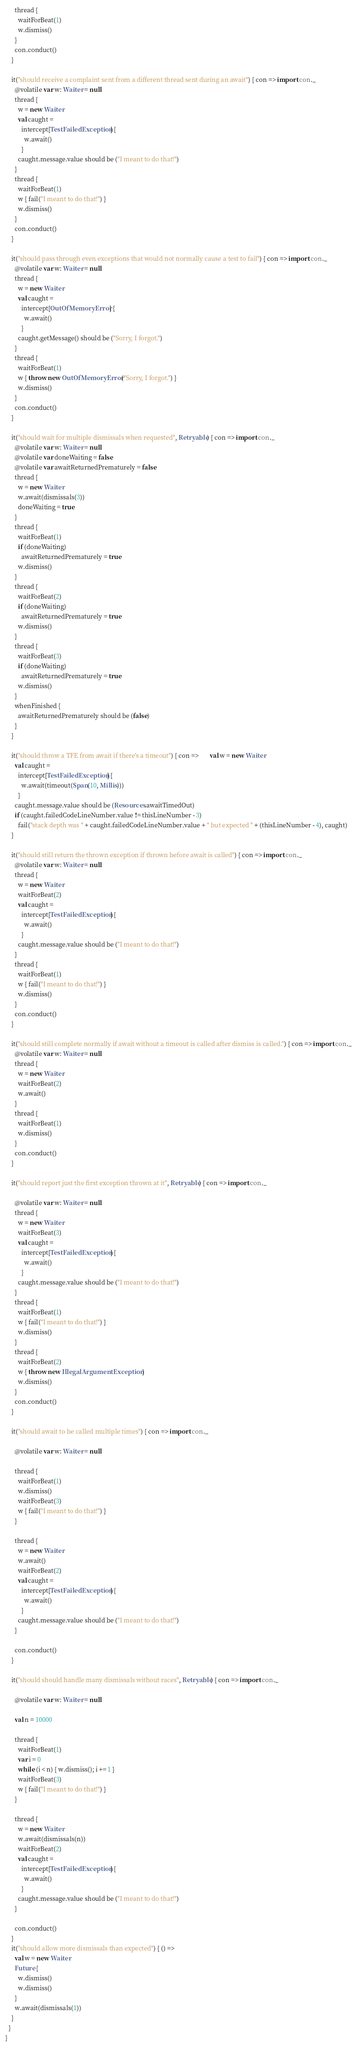<code> <loc_0><loc_0><loc_500><loc_500><_Scala_>      thread {
        waitForBeat(1)
        w.dismiss()
      }
      con.conduct()
    }

    it("should receive a complaint sent from a different thread sent during an await") { con => import con._
      @volatile var w: Waiter = null
      thread {
        w = new Waiter
        val caught =
          intercept[TestFailedException] {
            w.await()
          }
        caught.message.value should be ("I meant to do that!")
      }
      thread {
        waitForBeat(1)
        w { fail("I meant to do that!") }
        w.dismiss()
      }
      con.conduct()
    }

    it("should pass through even exceptions that would not normally cause a test to fail") { con => import con._
      @volatile var w: Waiter = null
      thread {
        w = new Waiter
        val caught =
          intercept[OutOfMemoryError] {
            w.await()
          }
        caught.getMessage() should be ("Sorry, I forgot.")
      }
      thread {
        waitForBeat(1)
        w { throw new OutOfMemoryError("Sorry, I forgot.") }
        w.dismiss()
      }
      con.conduct()
    }

    it("should wait for multiple dismissals when requested", Retryable) { con => import con._
      @volatile var w: Waiter = null
      @volatile var doneWaiting = false
      @volatile var awaitReturnedPrematurely = false
      thread {
        w = new Waiter
        w.await(dismissals(3))
        doneWaiting = true
      }
      thread {
        waitForBeat(1)
        if (doneWaiting)
          awaitReturnedPrematurely = true
        w.dismiss()
      }
      thread {
        waitForBeat(2)
        if (doneWaiting)
          awaitReturnedPrematurely = true
        w.dismiss()
      }
      thread {
        waitForBeat(3)
        if (doneWaiting)
          awaitReturnedPrematurely = true
        w.dismiss()
      }
      whenFinished {
        awaitReturnedPrematurely should be (false)
      }
    }

    it("should throw a TFE from await if there's a timeout") { con =>       val w = new Waiter
      val caught =
        intercept[TestFailedException] {
          w.await(timeout(Span(10, Millis)))
        }
      caught.message.value should be (Resources.awaitTimedOut)
      if (caught.failedCodeLineNumber.value != thisLineNumber - 3)
        fail("stack depth was " + caught.failedCodeLineNumber.value + " but expected " + (thisLineNumber - 4), caught)
    }

    it("should still return the thrown exception if thrown before await is called") { con => import con._
      @volatile var w: Waiter = null
      thread {
        w = new Waiter
        waitForBeat(2)
        val caught =
          intercept[TestFailedException] {
            w.await()
          }
        caught.message.value should be ("I meant to do that!")
      }
      thread {
        waitForBeat(1)
        w { fail("I meant to do that!") }
        w.dismiss()
      }
      con.conduct()
    }

    it("should still complete normally if await without a timeout is called after dismiss is called.") { con => import con._
      @volatile var w: Waiter = null
      thread {
        w = new Waiter
        waitForBeat(2)
        w.await()
      }
      thread {
        waitForBeat(1)
        w.dismiss()
      }
      con.conduct()
    }

    it("should report just the first exception thrown at it", Retryable) { con => import con._

      @volatile var w: Waiter = null
      thread {
        w = new Waiter
        waitForBeat(3)
        val caught =
          intercept[TestFailedException] {
            w.await()
          }
        caught.message.value should be ("I meant to do that!")
      }
      thread {
        waitForBeat(1)
        w { fail("I meant to do that!") }
        w.dismiss()
      }
      thread {
        waitForBeat(2)
        w { throw new IllegalArgumentException }
        w.dismiss()
      }
      con.conduct()
    }

    it("should await to be called multiple times") { con => import con._

      @volatile var w: Waiter = null

      thread {
        waitForBeat(1)
        w.dismiss()
        waitForBeat(3)
        w { fail("I meant to do that!") }
      }

      thread {
        w = new Waiter
        w.await()
        waitForBeat(2)
        val caught =
          intercept[TestFailedException] {
            w.await()
          }
        caught.message.value should be ("I meant to do that!")
      }

      con.conduct()
    }

    it("should should handle many dismissals without races", Retryable) { con => import con._

      @volatile var w: Waiter = null

      val n = 10000

      thread {
        waitForBeat(1)
        var i = 0
        while (i < n) { w.dismiss(); i += 1 }
        waitForBeat(3)
        w { fail("I meant to do that!") }
      }

      thread {
        w = new Waiter
        w.await(dismissals(n))
        waitForBeat(2)
        val caught =
          intercept[TestFailedException] {
            w.await()
          }
        caught.message.value should be ("I meant to do that!")
      }

      con.conduct()
    }
    it("should allow more dismissals than expected") { () =>
      val w = new Waiter
      Future {
        w.dismiss()
        w.dismiss()
      }
      w.await(dismissals(1))
    }
  }
}
</code> 